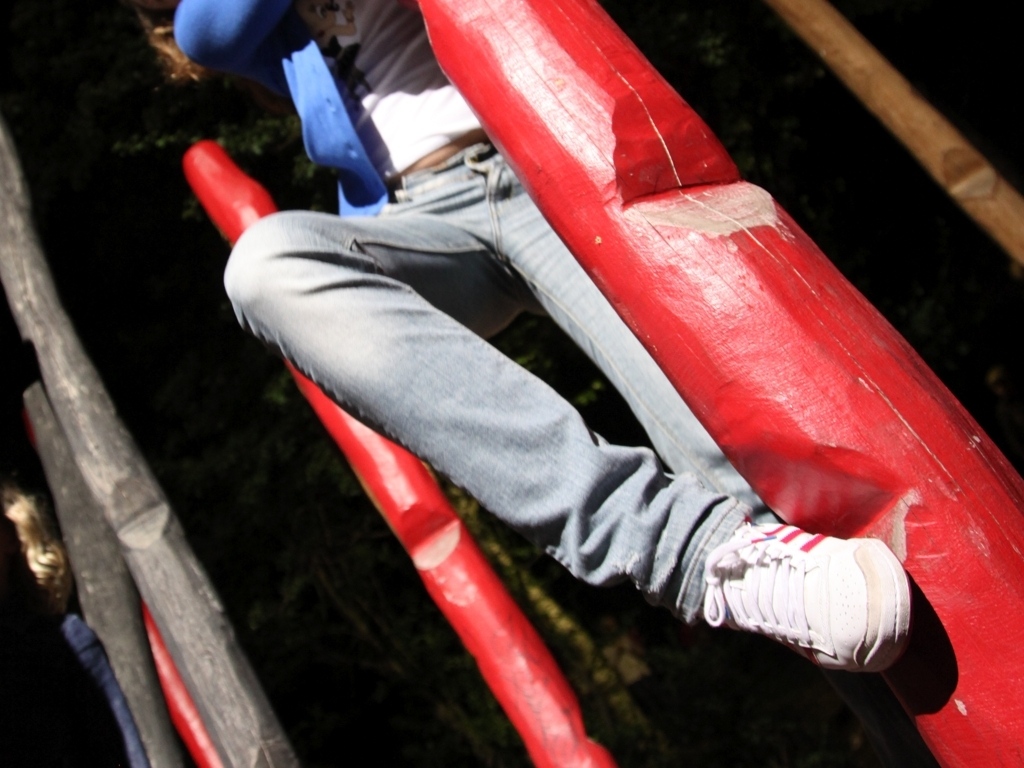What time of day does the image appear to be taken? The abundance of natural light and the shadows cast suggest that the photograph was likely taken during daylight hours, possibly in the late morning or early afternoon. 